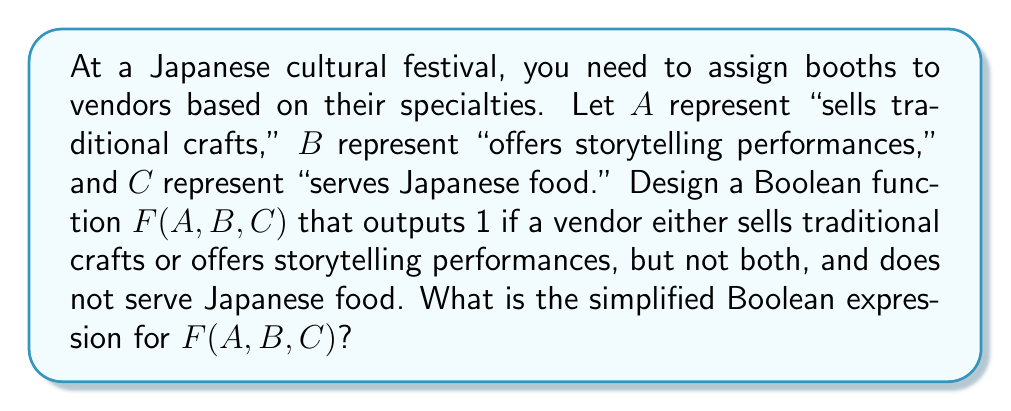Can you answer this question? Let's approach this step-by-step:

1) First, we need to translate the conditions into Boolean logic:
   - Either sells traditional crafts (A) or offers storytelling performances (B), but not both
   - Does not serve Japanese food (NOT C)

2) The "either A or B, but not both" condition is represented by the XOR operation, denoted as $\oplus$.

3) The "does not serve Japanese food" condition is represented by $\overline{C}$ (NOT C).

4) Combining these conditions, we get:
   $F(A,B,C) = (A \oplus B) \cdot \overline{C}$

5) We can expand the XOR operation:
   $A \oplus B = A\overline{B} + \overline{A}B$

6) Substituting this back into our function:
   $F(A,B,C) = (A\overline{B} + \overline{A}B) \cdot \overline{C}$

7) Using the distributive property:
   $F(A,B,C) = A\overline{B}\overline{C} + \overline{A}B\overline{C}$

This is the simplified Boolean expression for F(A,B,C).
Answer: $A\overline{B}\overline{C} + \overline{A}B\overline{C}$ 